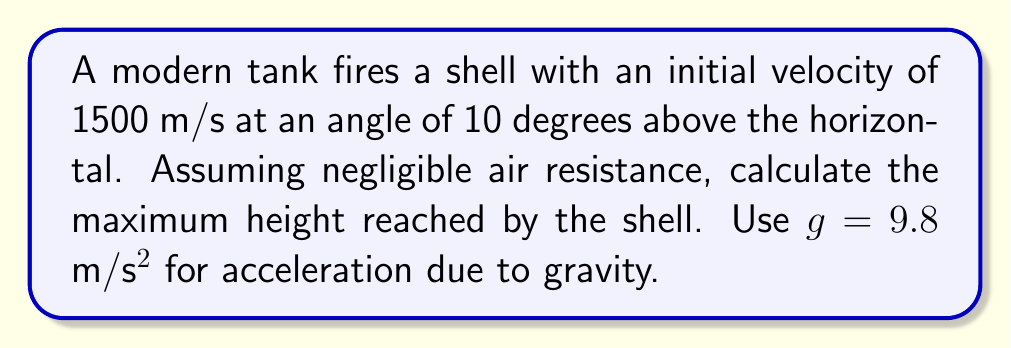Can you solve this math problem? Let's approach this step-by-step using differential equations:

1) First, we need to set up our coordinate system. Let $x$ be the horizontal distance and $y$ be the vertical distance.

2) The initial velocity components are:
   $v_x = 1500 \cos(10°)$ m/s
   $v_y = 1500 \sin(10°)$ m/s

3) The equations of motion for the shell are:
   $$\frac{d^2x}{dt^2} = 0$$
   $$\frac{d^2y}{dt^2} = -g$$

4) Integrating these equations once:
   $$\frac{dx}{dt} = v_x = 1500 \cos(10°)$$
   $$\frac{dy}{dt} = v_y = 1500 \sin(10°) - gt$$

5) The shell reaches its maximum height when $\frac{dy}{dt} = 0$. So:
   $$0 = 1500 \sin(10°) - gt_{max}$$
   $$t_{max} = \frac{1500 \sin(10°)}{g}$$

6) Now, integrating the equation for $y$ again:
   $$y = 1500 \sin(10°)t - \frac{1}{2}gt^2$$

7) The maximum height is reached at $t_{max}$, so substituting:
   $$y_{max} = 1500 \sin(10°) \cdot \frac{1500 \sin(10°)}{g} - \frac{1}{2}g \cdot (\frac{1500 \sin(10°)}{g})^2$$

8) Simplifying:
   $$y_{max} = \frac{(1500 \sin(10°))^2}{2g}$$

9) Calculating the result:
   $$y_{max} = \frac{(1500 \cdot 0.1736)^2}{2 \cdot 9.8} \approx 1098.85$$ meters
Answer: 1098.85 meters 